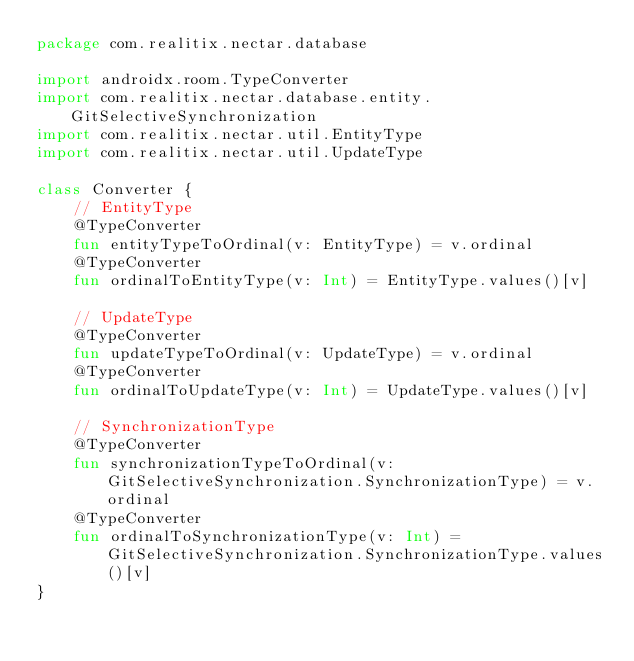Convert code to text. <code><loc_0><loc_0><loc_500><loc_500><_Kotlin_>package com.realitix.nectar.database

import androidx.room.TypeConverter
import com.realitix.nectar.database.entity.GitSelectiveSynchronization
import com.realitix.nectar.util.EntityType
import com.realitix.nectar.util.UpdateType

class Converter {
    // EntityType
    @TypeConverter
    fun entityTypeToOrdinal(v: EntityType) = v.ordinal
    @TypeConverter
    fun ordinalToEntityType(v: Int) = EntityType.values()[v]

    // UpdateType
    @TypeConverter
    fun updateTypeToOrdinal(v: UpdateType) = v.ordinal
    @TypeConverter
    fun ordinalToUpdateType(v: Int) = UpdateType.values()[v]

    // SynchronizationType
    @TypeConverter
    fun synchronizationTypeToOrdinal(v: GitSelectiveSynchronization.SynchronizationType) = v.ordinal
    @TypeConverter
    fun ordinalToSynchronizationType(v: Int) = GitSelectiveSynchronization.SynchronizationType.values()[v]
}</code> 